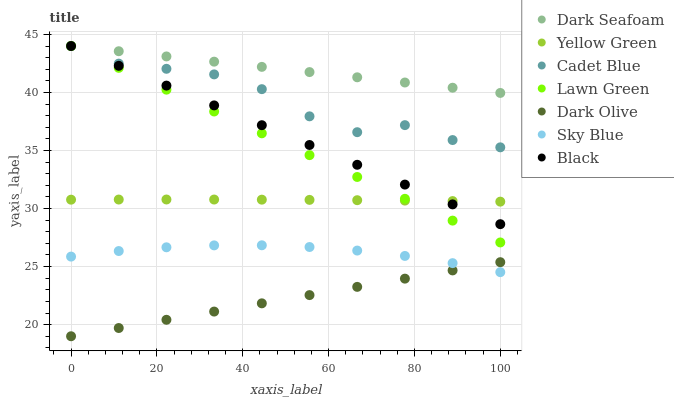Does Dark Olive have the minimum area under the curve?
Answer yes or no. Yes. Does Dark Seafoam have the maximum area under the curve?
Answer yes or no. Yes. Does Cadet Blue have the minimum area under the curve?
Answer yes or no. No. Does Cadet Blue have the maximum area under the curve?
Answer yes or no. No. Is Lawn Green the smoothest?
Answer yes or no. Yes. Is Cadet Blue the roughest?
Answer yes or no. Yes. Is Yellow Green the smoothest?
Answer yes or no. No. Is Yellow Green the roughest?
Answer yes or no. No. Does Dark Olive have the lowest value?
Answer yes or no. Yes. Does Cadet Blue have the lowest value?
Answer yes or no. No. Does Black have the highest value?
Answer yes or no. Yes. Does Yellow Green have the highest value?
Answer yes or no. No. Is Sky Blue less than Dark Seafoam?
Answer yes or no. Yes. Is Cadet Blue greater than Sky Blue?
Answer yes or no. Yes. Does Cadet Blue intersect Lawn Green?
Answer yes or no. Yes. Is Cadet Blue less than Lawn Green?
Answer yes or no. No. Is Cadet Blue greater than Lawn Green?
Answer yes or no. No. Does Sky Blue intersect Dark Seafoam?
Answer yes or no. No. 